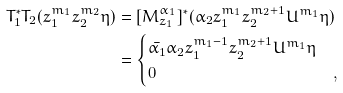<formula> <loc_0><loc_0><loc_500><loc_500>T _ { 1 } ^ { * } T _ { 2 } ( z _ { 1 } ^ { m _ { 1 } } z _ { 2 } ^ { m _ { 2 } } \eta ) & = [ M _ { z _ { 1 } } ^ { \alpha _ { 1 } } ] ^ { * } ( \alpha _ { 2 } z _ { 1 } ^ { m _ { 1 } } z _ { 2 } ^ { m _ { 2 } + 1 } U ^ { m _ { 1 } } \eta ) \\ & = \begin{cases} \bar { \alpha _ { 1 } } \alpha _ { 2 } z _ { 1 } ^ { m _ { 1 } - 1 } z _ { 2 } ^ { m _ { 2 } + 1 } U ^ { m _ { 1 } } \eta & \\ 0 & , \end{cases}</formula> 